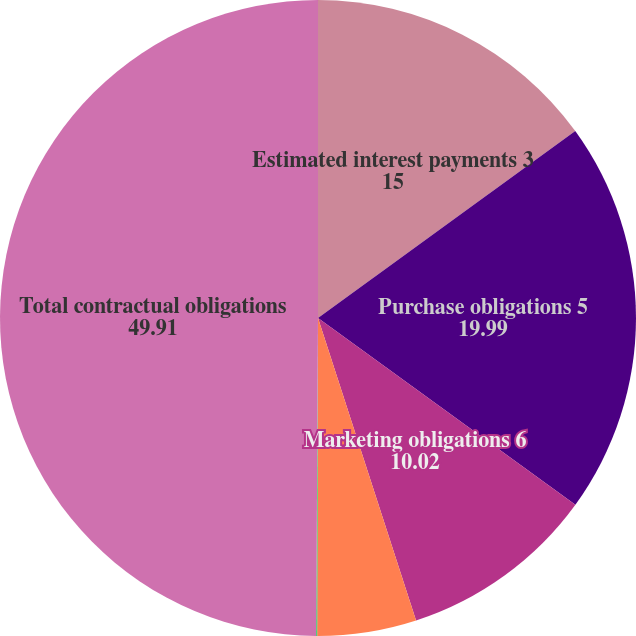Convert chart to OTSL. <chart><loc_0><loc_0><loc_500><loc_500><pie_chart><fcel>Estimated interest payments 3<fcel>Purchase obligations 5<fcel>Marketing obligations 6<fcel>Lease obligations<fcel>Held-for-sale obligations 7<fcel>Total contractual obligations<nl><fcel>15.0%<fcel>19.99%<fcel>10.02%<fcel>5.03%<fcel>0.05%<fcel>49.91%<nl></chart> 